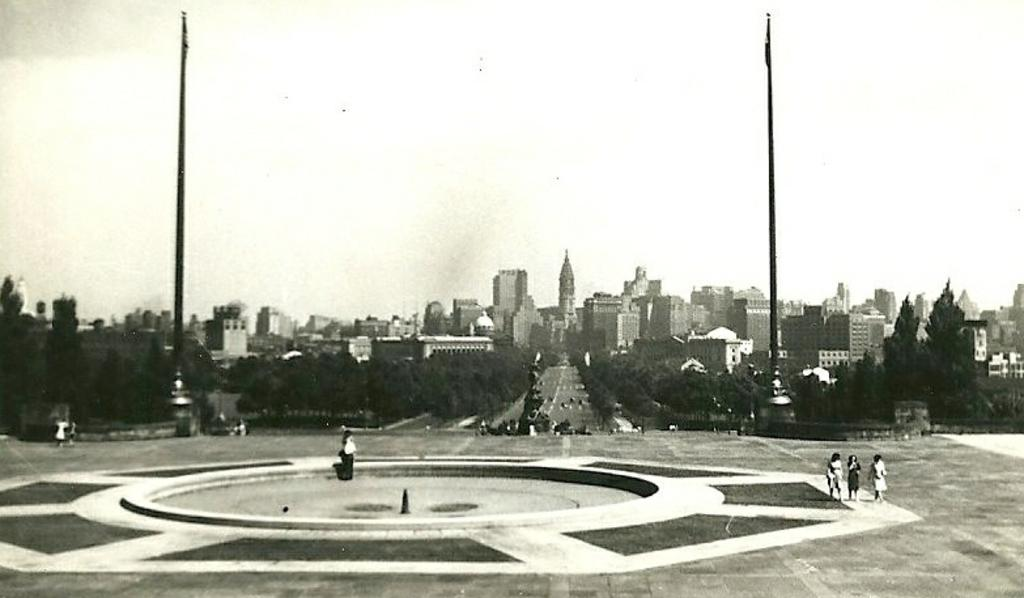What is happening in the center of the image? There are people standing in the center of the image. What objects can be seen in the image besides the people? There are poles in the image. What can be seen in the background of the image? The sky, clouds, trees, buildings, and vehicles on the road are visible in the background of the image. Is there a beggar asking for money in the image? There is no mention of a beggar in the image, so we cannot confirm or deny their presence. 